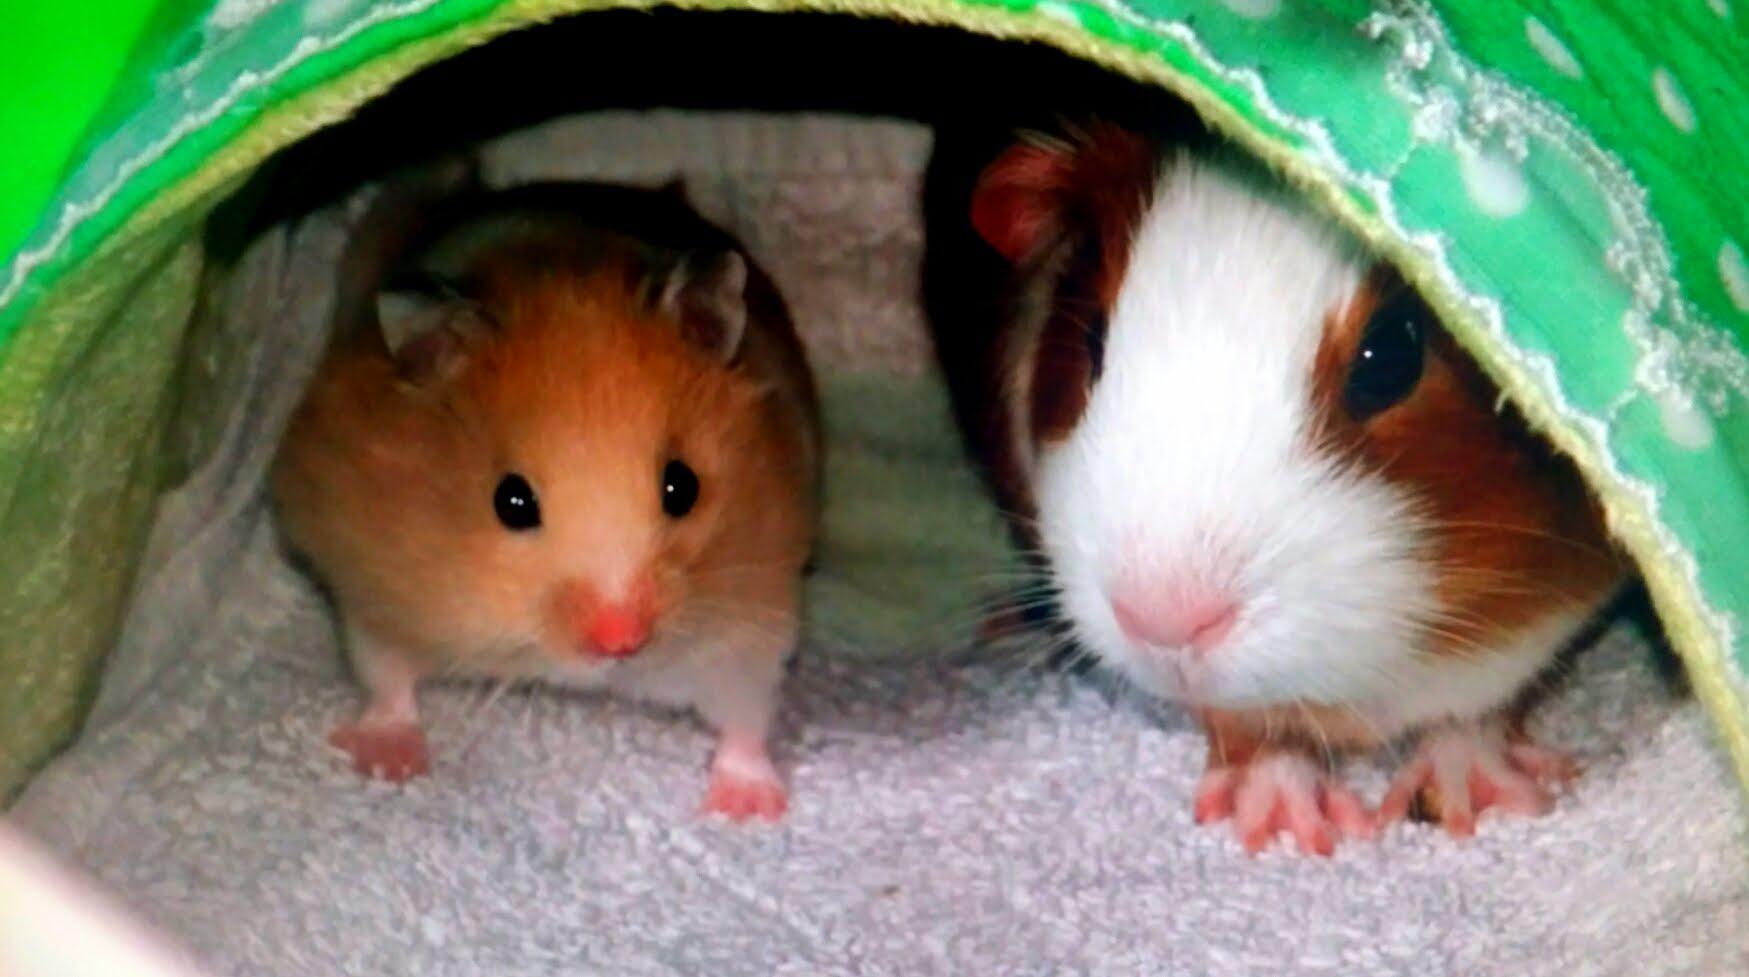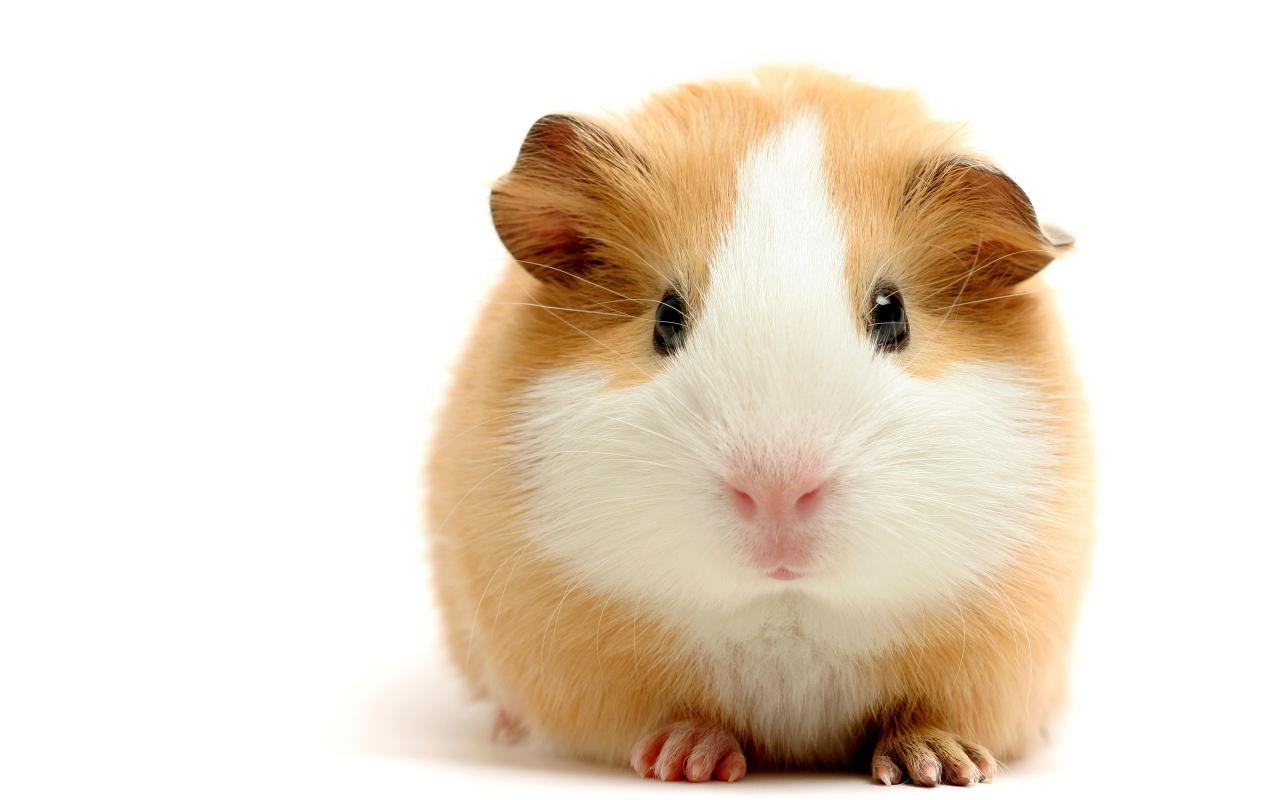The first image is the image on the left, the second image is the image on the right. Given the left and right images, does the statement "A total of three rodent-type pets are shown." hold true? Answer yes or no. Yes. 